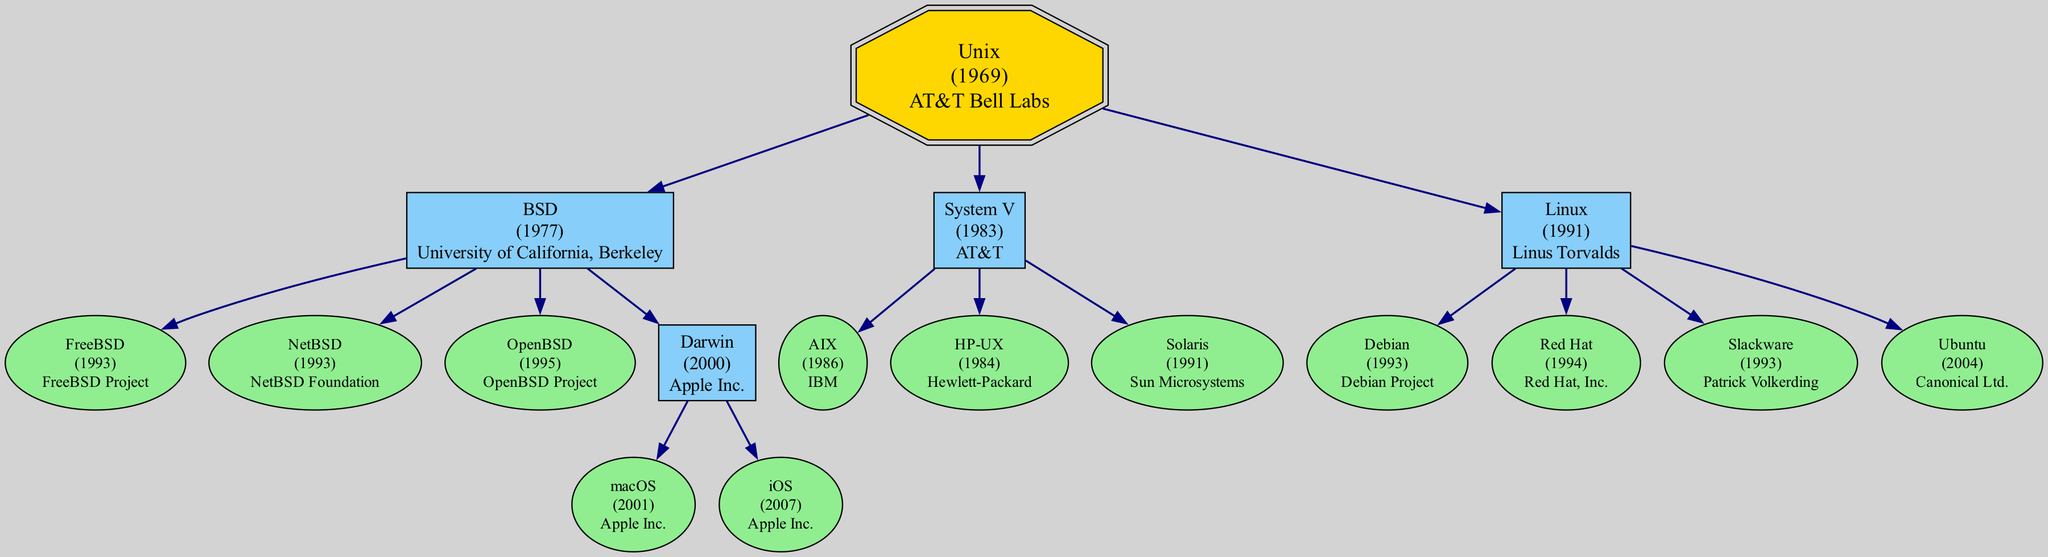What is the release year of Unix? The diagram specifies that Unix was released in 1969, which is indicated next to the node for Unix.
Answer: 1969 Which operating system is developed by Apple Inc. and released in 2001? The diagram shows that macOS is the operating system developed by Apple Inc. and it has a release year of 2001, as detailed in its node.
Answer: macOS How many children does BSD have? By examining the BSD node, the diagram shows that BSD has four children: FreeBSD, NetBSD, OpenBSD, and Darwin, so the count of children is derived from the number of connected nodes under BSD.
Answer: 4 Which operating system was released first, AIX or Solaris? The nodes for AIX and Solaris indicate their release years of 1986 and 1991, respectively. Since 1986 is earlier than 1991, we see that AIX was released before Solaris.
Answer: AIX What is the latest release year in the entire family tree? The nodes with their respective release years should be compared. The latest release years in the diagram are 2007 for iOS and 2004 for Ubuntu. Identifying the maximum among these, iOS is the latest.
Answer: 2007 Is Linux developed by a single entity? The node for Linux states that it was developed by Linus Torvalds. Since no additional developers are listed, it confirms that Linux is attributed solely to Linus.
Answer: Linus Torvalds How many operating systems descend directly from System V? Looking at the System V node, it has three direct children: AIX, HP-UX, and Solaris. To answer the question, simply count these child nodes.
Answer: 3 Which two Unix-based operating systems were released in 1993? Both FreeBSD and Slackware have release years listed as 1993 in the diagram. Since both are direct children of their respective nodes, their years can be easily identified and compared.
Answer: FreeBSD, Slackware Which Unix family has the earliest release year and what is it called? We observe from the root of the diagram that Unix has the earliest release year of 1969, clearly marked next to it indicating that it is the original Unix.
Answer: Unix 